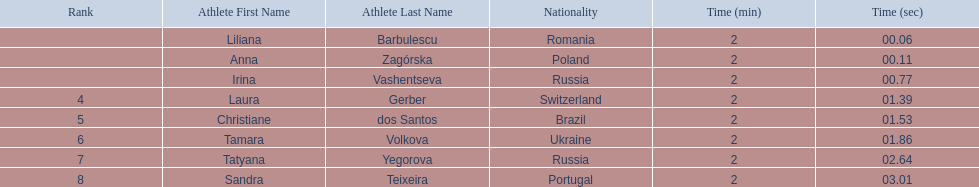Who were all of the athletes? Liliana Barbulescu, Anna Zagórska, Irina Vashentseva, Laura Gerber, Christiane dos Santos, Tamara Volkova, Tatyana Yegorova, Sandra Teixeira. What were their finishing times? 2:00.06, 2:00.11, 2:00.77, 2:01.39, 2:01.53, 2:01.86, 2:02.64, 2:03.01. Which athlete finished earliest? Liliana Barbulescu. 